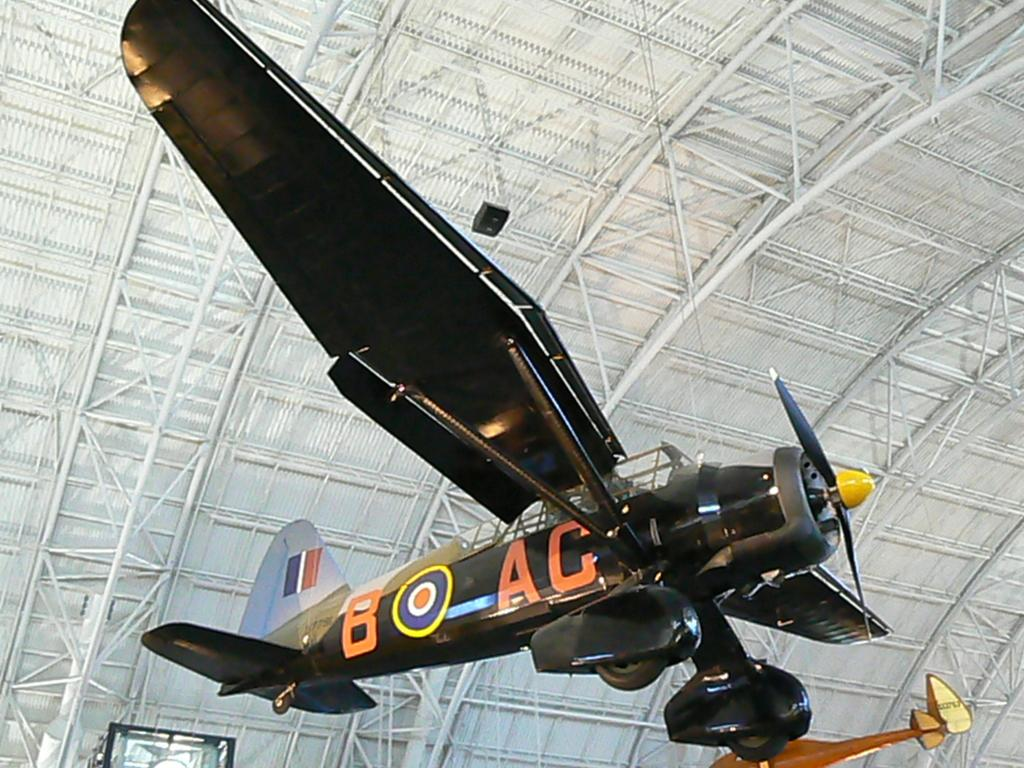<image>
Create a compact narrative representing the image presented. A plane with AC painted on its side is suspended from a ceiling. 